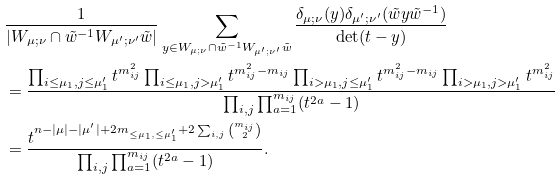<formula> <loc_0><loc_0><loc_500><loc_500>& \frac { 1 } { | W _ { \mu ; \nu } \cap \tilde { w } ^ { - 1 } W _ { \mu ^ { \prime } ; \nu ^ { \prime } } \tilde { w } | } \sum _ { y \in W _ { \mu ; \nu } \cap \tilde { w } ^ { - 1 } W _ { \mu ^ { \prime } ; \nu ^ { \prime } } \tilde { w } } \frac { \delta _ { \mu ; \nu } ( y ) \delta _ { \mu ^ { \prime } ; \nu ^ { \prime } } ( \tilde { w } y \tilde { w } ^ { - 1 } ) } { \det ( t - y ) } \\ & = \frac { \prod _ { i \leq \mu _ { 1 } , j \leq \mu _ { 1 } ^ { \prime } } t ^ { m _ { i j } ^ { 2 } } \prod _ { i \leq \mu _ { 1 } , j > \mu _ { 1 } ^ { \prime } } t ^ { m _ { i j } ^ { 2 } - m _ { i j } } \prod _ { i > \mu _ { 1 } , j \leq \mu _ { 1 } ^ { \prime } } t ^ { m _ { i j } ^ { 2 } - m _ { i j } } \prod _ { i > \mu _ { 1 } , j > \mu _ { 1 } ^ { \prime } } t ^ { m _ { i j } ^ { 2 } } } { \prod _ { i , j } \prod _ { a = 1 } ^ { m _ { i j } } ( t ^ { 2 a } - 1 ) } \\ & = \frac { t ^ { n - | \mu | - | \mu ^ { \prime } | + 2 m _ { \leq \mu _ { 1 } , \leq \mu _ { 1 } ^ { \prime } } + 2 \sum _ { i , j } \binom { m _ { i j } } { 2 } } } { \prod _ { i , j } \prod _ { a = 1 } ^ { m _ { i j } } ( t ^ { 2 a } - 1 ) } .</formula> 